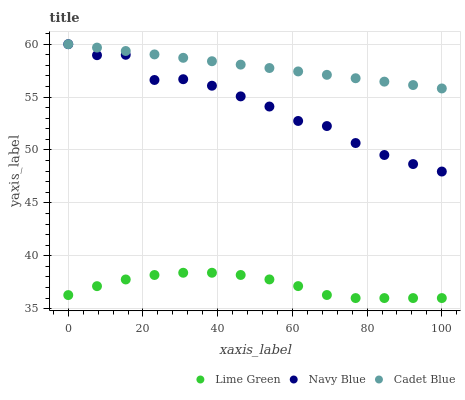Does Lime Green have the minimum area under the curve?
Answer yes or no. Yes. Does Cadet Blue have the maximum area under the curve?
Answer yes or no. Yes. Does Cadet Blue have the minimum area under the curve?
Answer yes or no. No. Does Lime Green have the maximum area under the curve?
Answer yes or no. No. Is Cadet Blue the smoothest?
Answer yes or no. Yes. Is Navy Blue the roughest?
Answer yes or no. Yes. Is Lime Green the smoothest?
Answer yes or no. No. Is Lime Green the roughest?
Answer yes or no. No. Does Lime Green have the lowest value?
Answer yes or no. Yes. Does Cadet Blue have the lowest value?
Answer yes or no. No. Does Cadet Blue have the highest value?
Answer yes or no. Yes. Does Lime Green have the highest value?
Answer yes or no. No. Is Lime Green less than Navy Blue?
Answer yes or no. Yes. Is Navy Blue greater than Lime Green?
Answer yes or no. Yes. Does Navy Blue intersect Cadet Blue?
Answer yes or no. Yes. Is Navy Blue less than Cadet Blue?
Answer yes or no. No. Is Navy Blue greater than Cadet Blue?
Answer yes or no. No. Does Lime Green intersect Navy Blue?
Answer yes or no. No. 